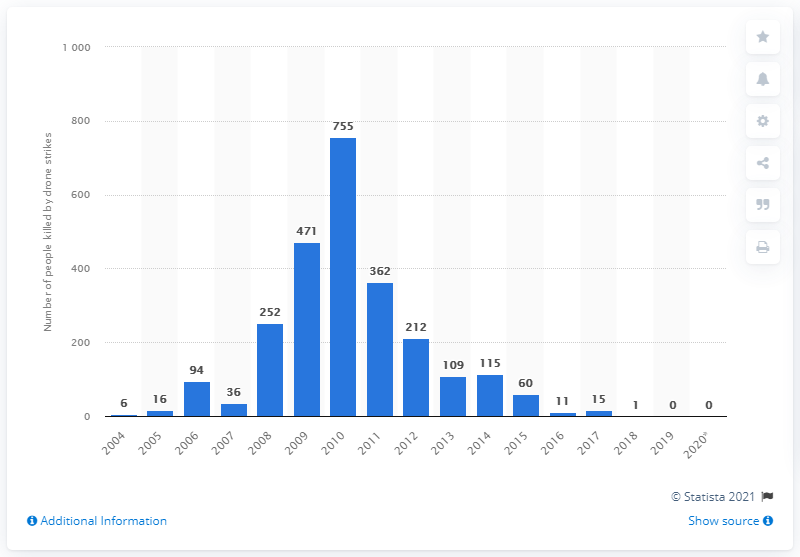Indicate a few pertinent items in this graphic. In 2019, there were no reported drone strikes carried out by the United States in Pakistan. 